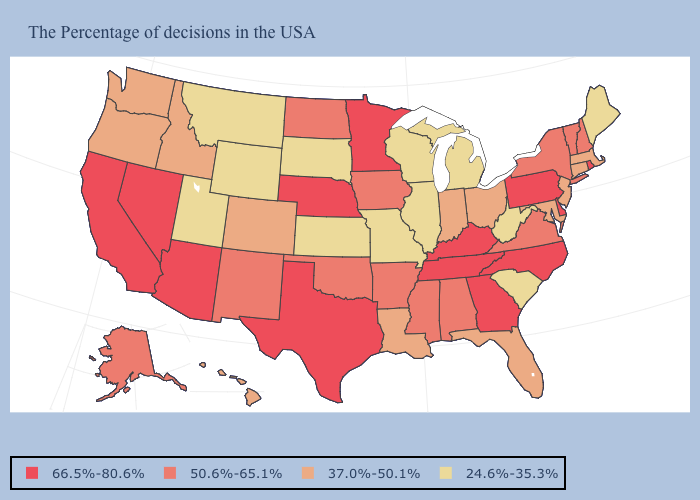What is the highest value in states that border Oklahoma?
Concise answer only. 66.5%-80.6%. Among the states that border Colorado , which have the lowest value?
Concise answer only. Kansas, Wyoming, Utah. What is the value of North Carolina?
Short answer required. 66.5%-80.6%. Which states hav the highest value in the West?
Keep it brief. Arizona, Nevada, California. What is the lowest value in the MidWest?
Answer briefly. 24.6%-35.3%. Name the states that have a value in the range 66.5%-80.6%?
Be succinct. Rhode Island, Delaware, Pennsylvania, North Carolina, Georgia, Kentucky, Tennessee, Minnesota, Nebraska, Texas, Arizona, Nevada, California. Does the map have missing data?
Concise answer only. No. What is the highest value in the West ?
Quick response, please. 66.5%-80.6%. What is the lowest value in states that border Louisiana?
Write a very short answer. 50.6%-65.1%. Does the map have missing data?
Concise answer only. No. Among the states that border Delaware , which have the lowest value?
Give a very brief answer. New Jersey, Maryland. Among the states that border Louisiana , does Arkansas have the highest value?
Be succinct. No. Which states have the lowest value in the USA?
Give a very brief answer. Maine, South Carolina, West Virginia, Michigan, Wisconsin, Illinois, Missouri, Kansas, South Dakota, Wyoming, Utah, Montana. What is the highest value in the USA?
Be succinct. 66.5%-80.6%. What is the highest value in states that border Vermont?
Concise answer only. 50.6%-65.1%. 